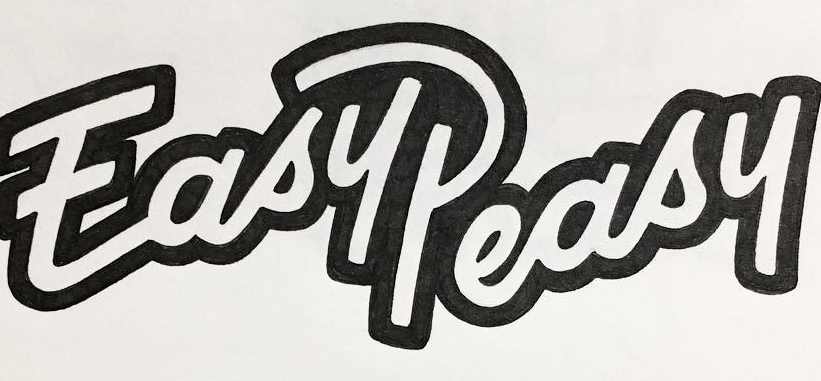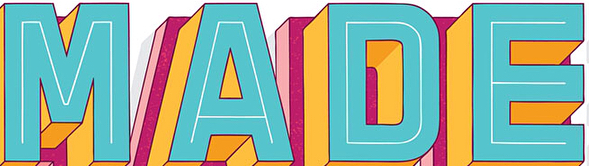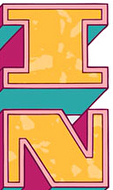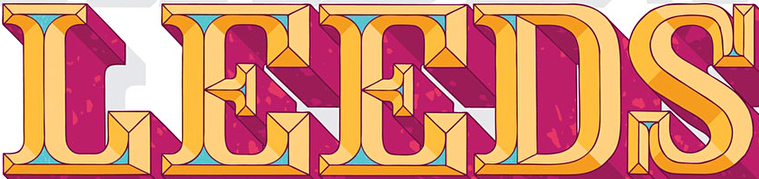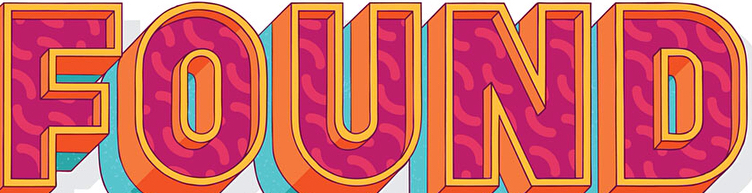Transcribe the words shown in these images in order, separated by a semicolon. EasyPeasy; MADE; IN; LEEDS; FOUND 